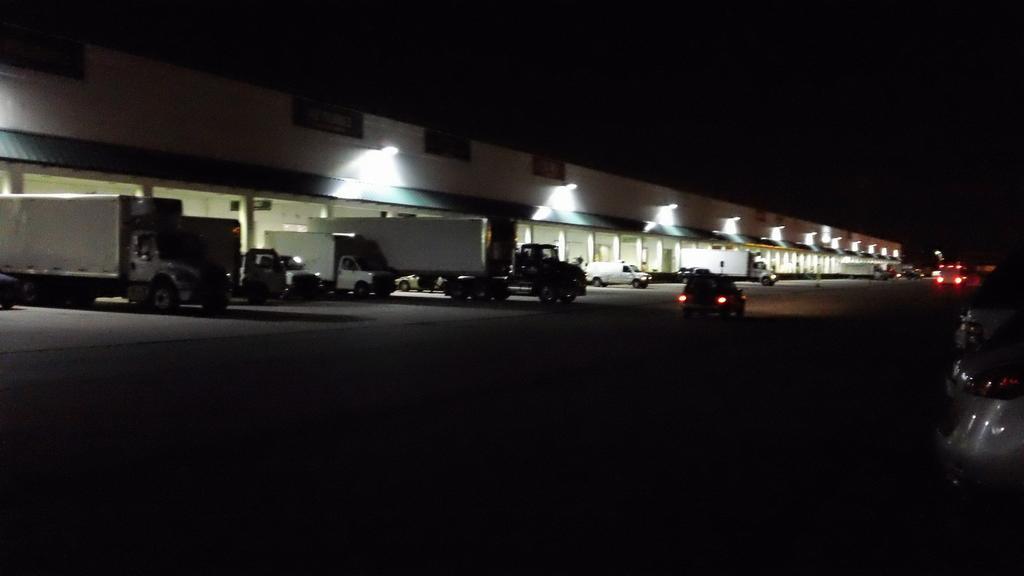Could you give a brief overview of what you see in this image? In this picture we can see a few vehicles on the path. There are a few pillars, lights and boards are visible on a building. We can see the dark view on top and at the bottom of the picture. 